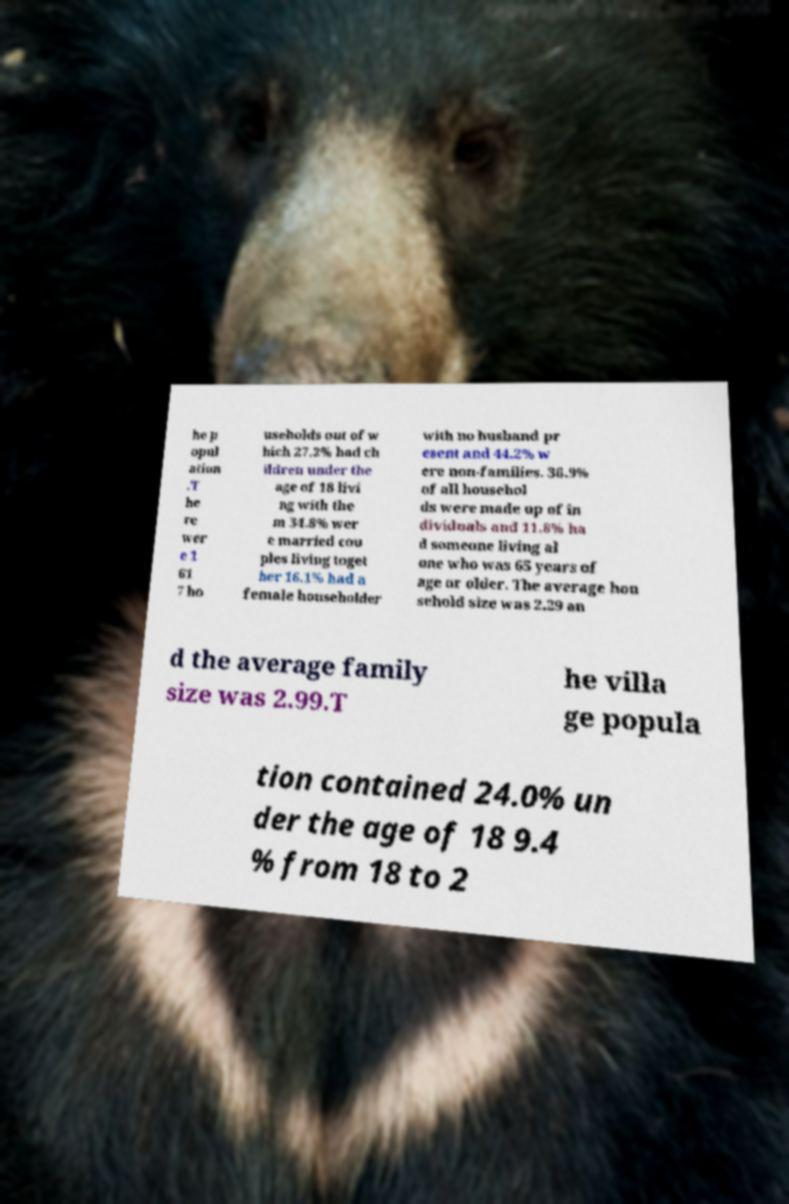Could you assist in decoding the text presented in this image and type it out clearly? he p opul ation .T he re wer e 1 61 7 ho useholds out of w hich 27.2% had ch ildren under the age of 18 livi ng with the m 34.8% wer e married cou ples living toget her 16.1% had a female householder with no husband pr esent and 44.2% w ere non-families. 36.9% of all househol ds were made up of in dividuals and 11.8% ha d someone living al one who was 65 years of age or older. The average hou sehold size was 2.29 an d the average family size was 2.99.T he villa ge popula tion contained 24.0% un der the age of 18 9.4 % from 18 to 2 